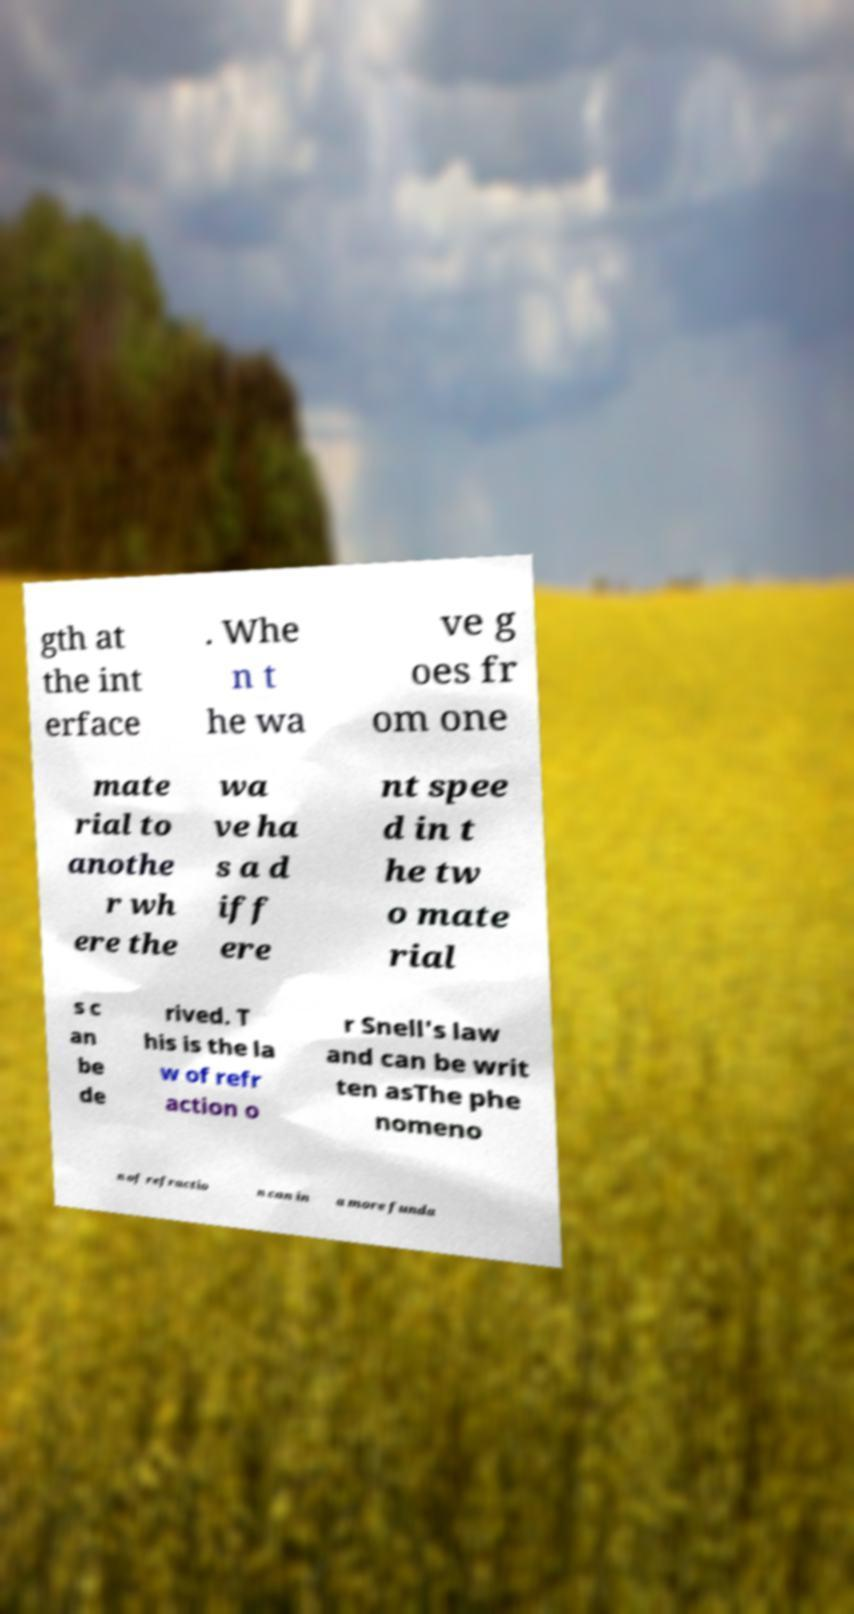Could you assist in decoding the text presented in this image and type it out clearly? gth at the int erface . Whe n t he wa ve g oes fr om one mate rial to anothe r wh ere the wa ve ha s a d iff ere nt spee d in t he tw o mate rial s c an be de rived. T his is the la w of refr action o r Snell's law and can be writ ten asThe phe nomeno n of refractio n can in a more funda 